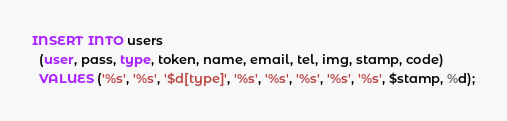<code> <loc_0><loc_0><loc_500><loc_500><_SQL_>
INSERT INTO users
  (user, pass, type, token, name, email, tel, img, stamp, code)
  VALUES ('%s', '%s', '$d[type]', '%s', '%s', '%s', '%s', '%s', $stamp, %d);</code> 